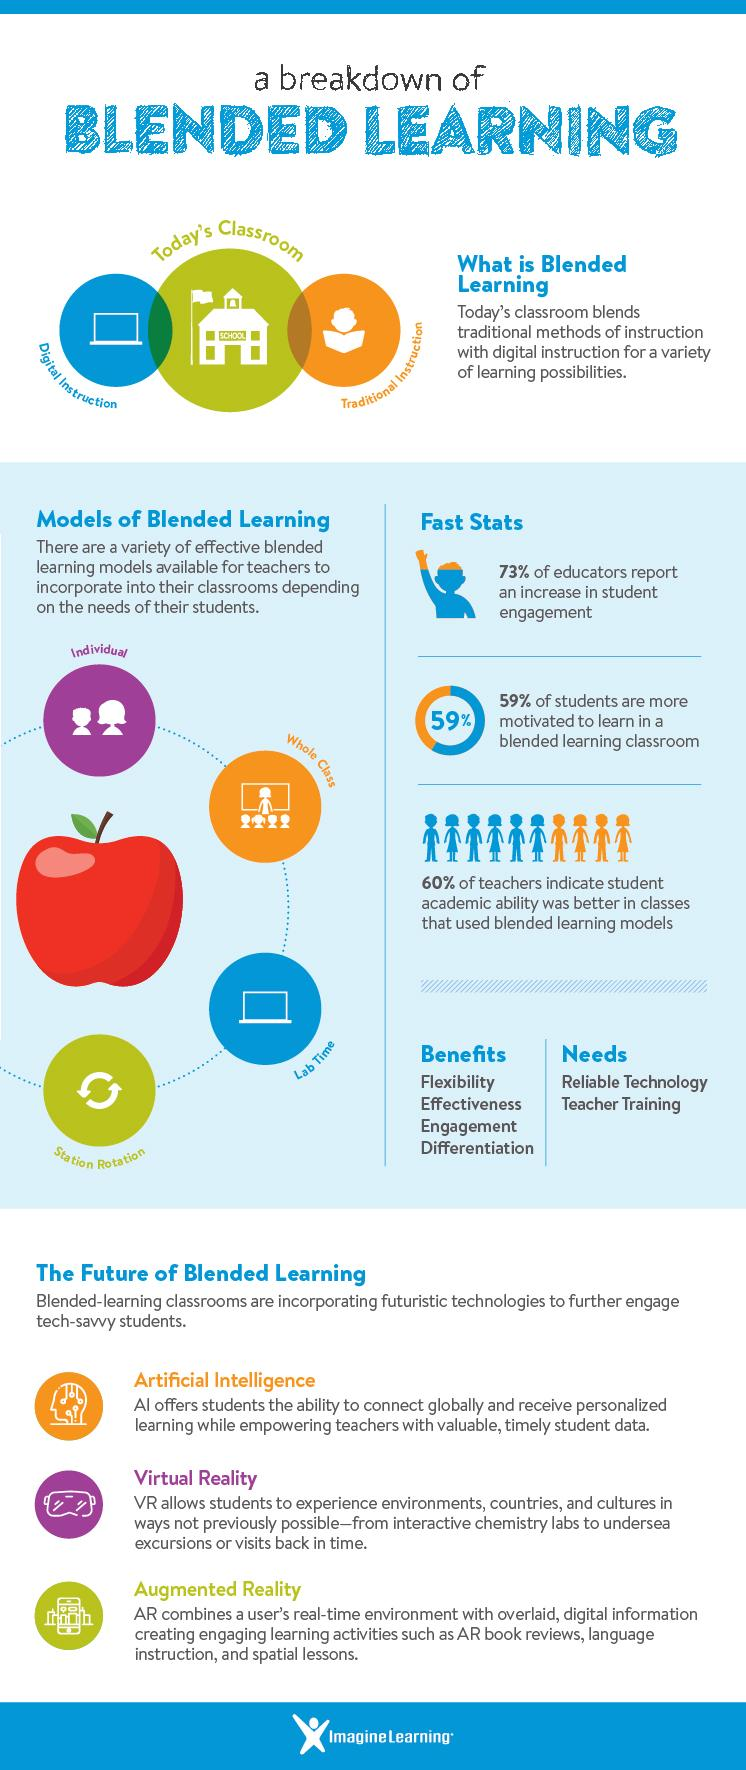Highlight a few significant elements in this photo. According to a study, a significant percentage of students, 59%, are more motivated to learn in a blended learning classroom compared to a traditional classroom. According to a study, only 27% of educators reported a decrease in student engagement in blended learning. 